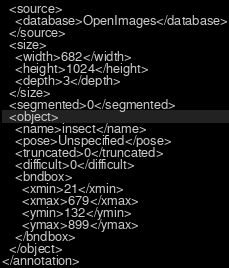Convert code to text. <code><loc_0><loc_0><loc_500><loc_500><_XML_>  <source>
    <database>OpenImages</database>
  </source>
  <size>
    <width>682</width>
    <height>1024</height>
    <depth>3</depth>
  </size>
  <segmented>0</segmented>
  <object>
    <name>insect</name>
    <pose>Unspecified</pose>
    <truncated>0</truncated>
    <difficult>0</difficult>
    <bndbox>
      <xmin>21</xmin>
      <xmax>679</xmax>
      <ymin>132</ymin>
      <ymax>899</ymax>
    </bndbox>
  </object>
</annotation>
</code> 